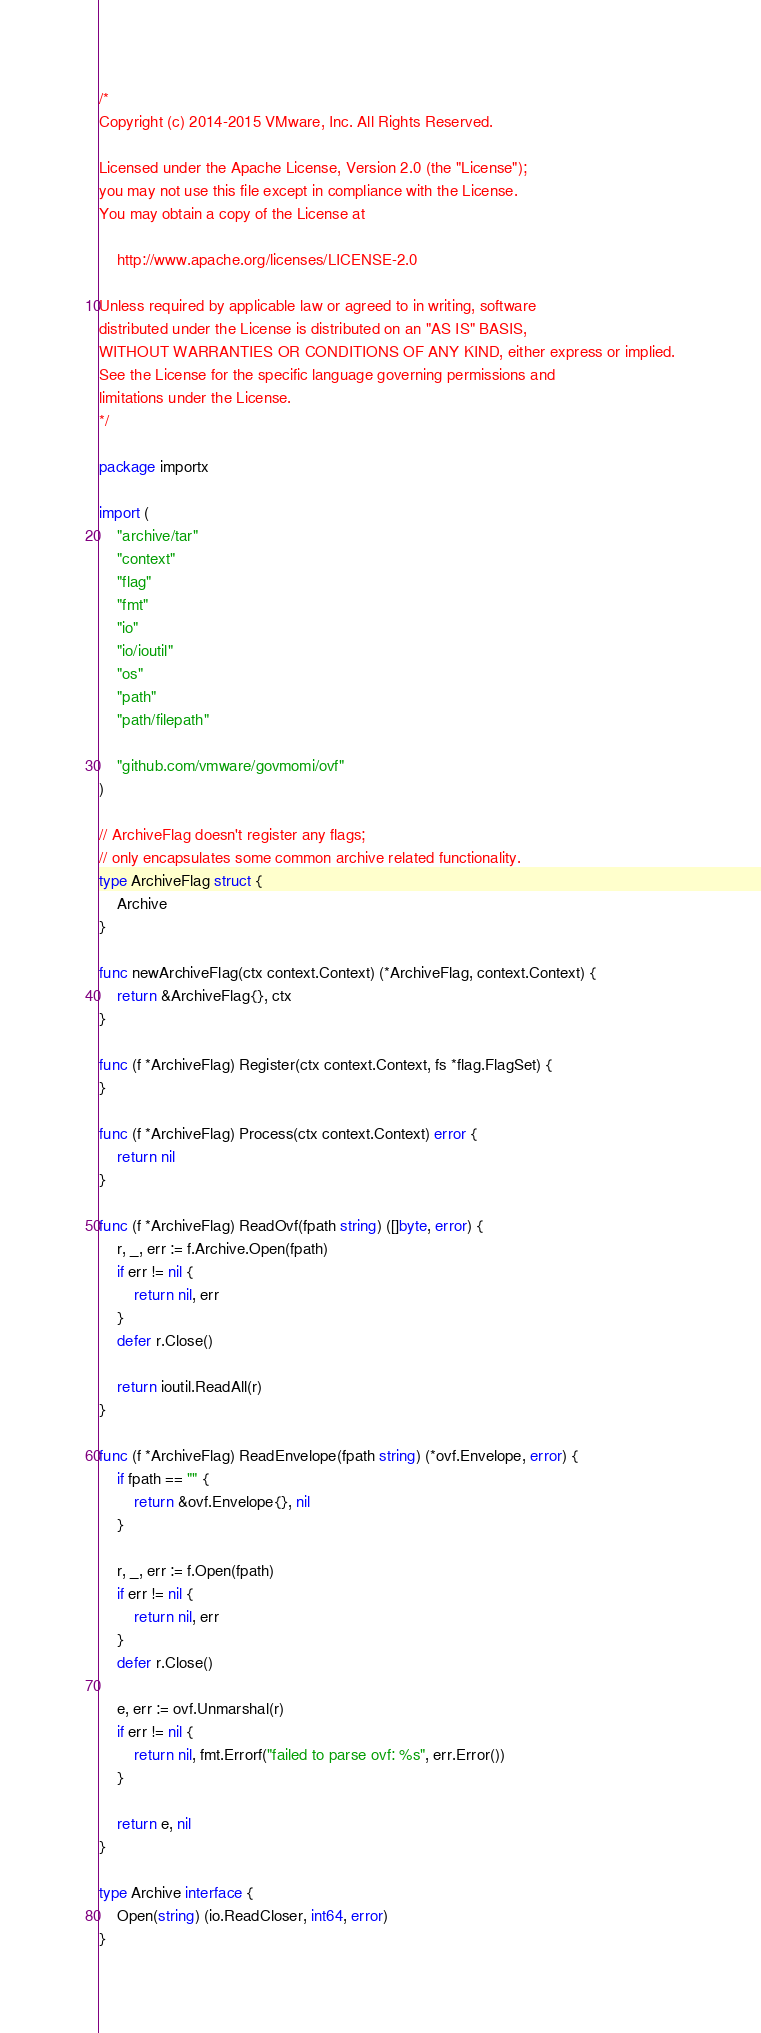Convert code to text. <code><loc_0><loc_0><loc_500><loc_500><_Go_>/*
Copyright (c) 2014-2015 VMware, Inc. All Rights Reserved.

Licensed under the Apache License, Version 2.0 (the "License");
you may not use this file except in compliance with the License.
You may obtain a copy of the License at

    http://www.apache.org/licenses/LICENSE-2.0

Unless required by applicable law or agreed to in writing, software
distributed under the License is distributed on an "AS IS" BASIS,
WITHOUT WARRANTIES OR CONDITIONS OF ANY KIND, either express or implied.
See the License for the specific language governing permissions and
limitations under the License.
*/

package importx

import (
	"archive/tar"
	"context"
	"flag"
	"fmt"
	"io"
	"io/ioutil"
	"os"
	"path"
	"path/filepath"

	"github.com/vmware/govmomi/ovf"
)

// ArchiveFlag doesn't register any flags;
// only encapsulates some common archive related functionality.
type ArchiveFlag struct {
	Archive
}

func newArchiveFlag(ctx context.Context) (*ArchiveFlag, context.Context) {
	return &ArchiveFlag{}, ctx
}

func (f *ArchiveFlag) Register(ctx context.Context, fs *flag.FlagSet) {
}

func (f *ArchiveFlag) Process(ctx context.Context) error {
	return nil
}

func (f *ArchiveFlag) ReadOvf(fpath string) ([]byte, error) {
	r, _, err := f.Archive.Open(fpath)
	if err != nil {
		return nil, err
	}
	defer r.Close()

	return ioutil.ReadAll(r)
}

func (f *ArchiveFlag) ReadEnvelope(fpath string) (*ovf.Envelope, error) {
	if fpath == "" {
		return &ovf.Envelope{}, nil
	}

	r, _, err := f.Open(fpath)
	if err != nil {
		return nil, err
	}
	defer r.Close()

	e, err := ovf.Unmarshal(r)
	if err != nil {
		return nil, fmt.Errorf("failed to parse ovf: %s", err.Error())
	}

	return e, nil
}

type Archive interface {
	Open(string) (io.ReadCloser, int64, error)
}
</code> 